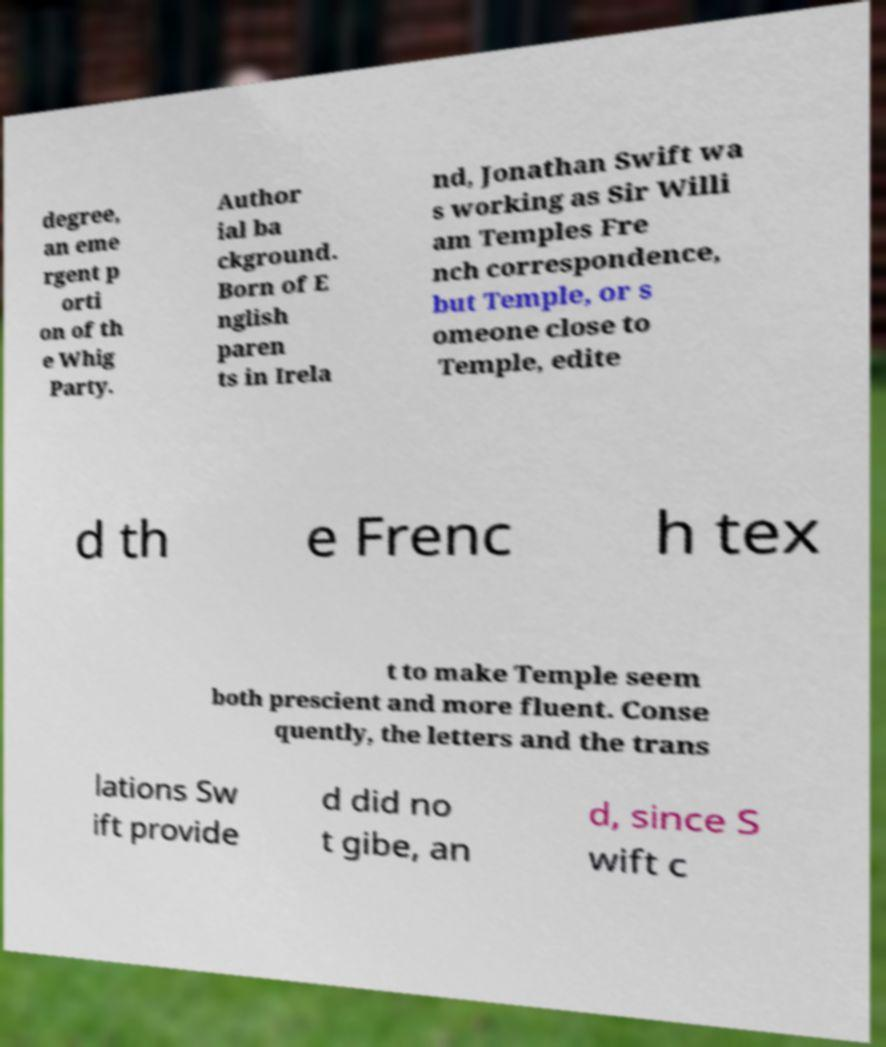Please read and relay the text visible in this image. What does it say? degree, an eme rgent p orti on of th e Whig Party. Author ial ba ckground. Born of E nglish paren ts in Irela nd, Jonathan Swift wa s working as Sir Willi am Temples Fre nch correspondence, but Temple, or s omeone close to Temple, edite d th e Frenc h tex t to make Temple seem both prescient and more fluent. Conse quently, the letters and the trans lations Sw ift provide d did no t gibe, an d, since S wift c 